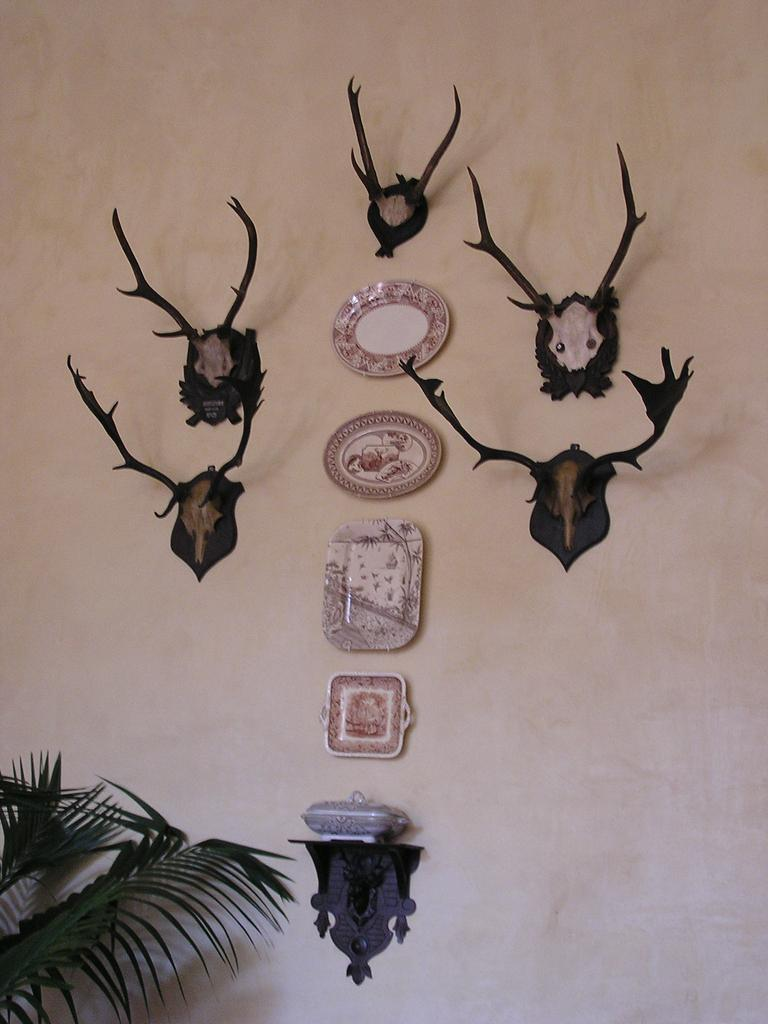What objects are hanging on the wall in the image? There are clocks and statues on the wall in the image. What type of plant is visible at the bottom of the image? There is a plant at the bottom of the image. Where is the calculator located in the image? There is no calculator present in the image. What type of show is being performed by the statues on the wall? The statues on the wall are not performing a show; they are stationary objects. 